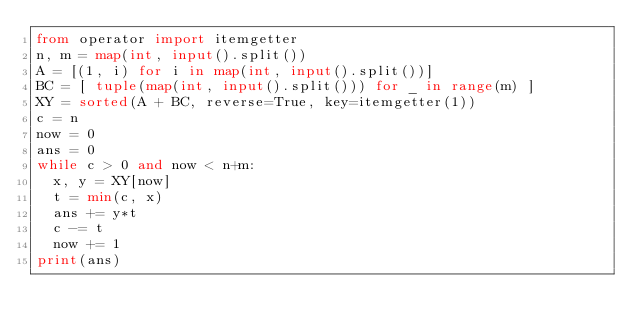Convert code to text. <code><loc_0><loc_0><loc_500><loc_500><_Python_>from operator import itemgetter
n, m = map(int, input().split())
A = [(1, i) for i in map(int, input().split())]
BC = [ tuple(map(int, input().split())) for _ in range(m) ]
XY = sorted(A + BC, reverse=True, key=itemgetter(1))
c = n
now = 0
ans = 0
while c > 0 and now < n+m:
  x, y = XY[now]
  t = min(c, x)
  ans += y*t
  c -= t
  now += 1
print(ans)</code> 